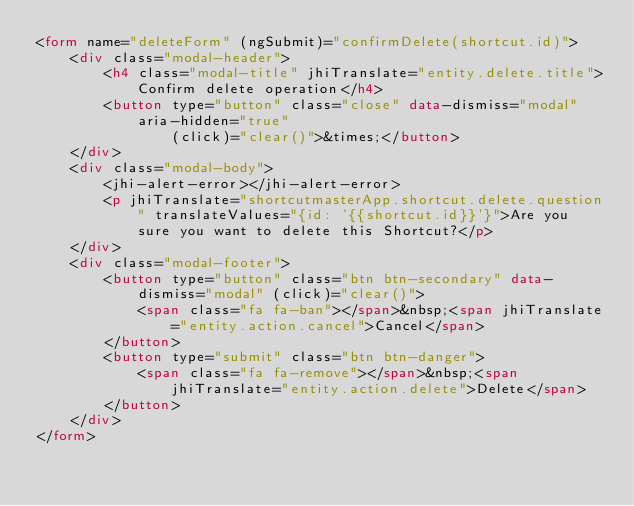<code> <loc_0><loc_0><loc_500><loc_500><_HTML_><form name="deleteForm" (ngSubmit)="confirmDelete(shortcut.id)">
    <div class="modal-header">
        <h4 class="modal-title" jhiTranslate="entity.delete.title">Confirm delete operation</h4>
        <button type="button" class="close" data-dismiss="modal" aria-hidden="true"
                (click)="clear()">&times;</button>
    </div>
    <div class="modal-body">
        <jhi-alert-error></jhi-alert-error>
        <p jhiTranslate="shortcutmasterApp.shortcut.delete.question" translateValues="{id: '{{shortcut.id}}'}">Are you sure you want to delete this Shortcut?</p>
    </div>
    <div class="modal-footer">
        <button type="button" class="btn btn-secondary" data-dismiss="modal" (click)="clear()">
            <span class="fa fa-ban"></span>&nbsp;<span jhiTranslate="entity.action.cancel">Cancel</span>
        </button>
        <button type="submit" class="btn btn-danger">
            <span class="fa fa-remove"></span>&nbsp;<span jhiTranslate="entity.action.delete">Delete</span>
        </button>
    </div>
</form>
</code> 